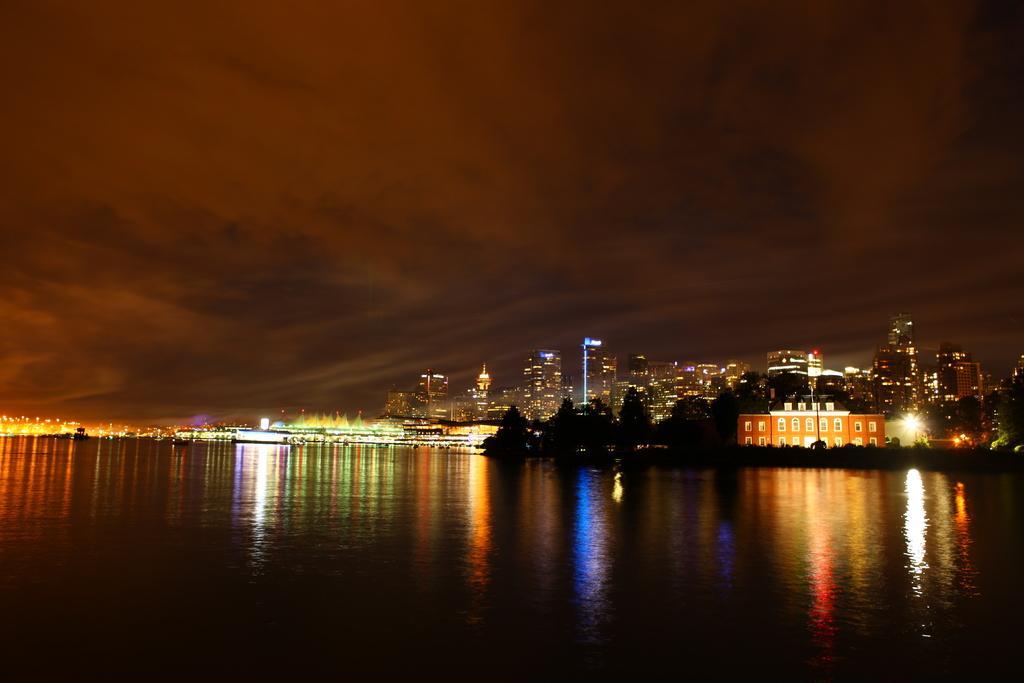Could you give a brief overview of what you see in this image? In this image we can see water, buildings, trees, ships, sky and clouds. 